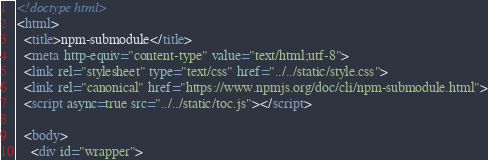<code> <loc_0><loc_0><loc_500><loc_500><_HTML_><!doctype html>
<html>
  <title>npm-submodule</title>
  <meta http-equiv="content-type" value="text/html;utf-8">
  <link rel="stylesheet" type="text/css" href="../../static/style.css">
  <link rel="canonical" href="https://www.npmjs.org/doc/cli/npm-submodule.html">
  <script async=true src="../../static/toc.js"></script>

  <body>
    <div id="wrapper">
</code> 